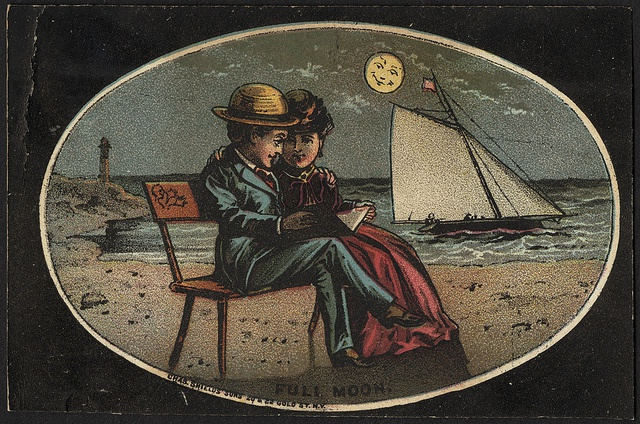Describe the objects in this image and their specific colors. I can see boat in black, tan, and gray tones, bench in black, gray, and maroon tones, and book in black, gray, and tan tones in this image. 